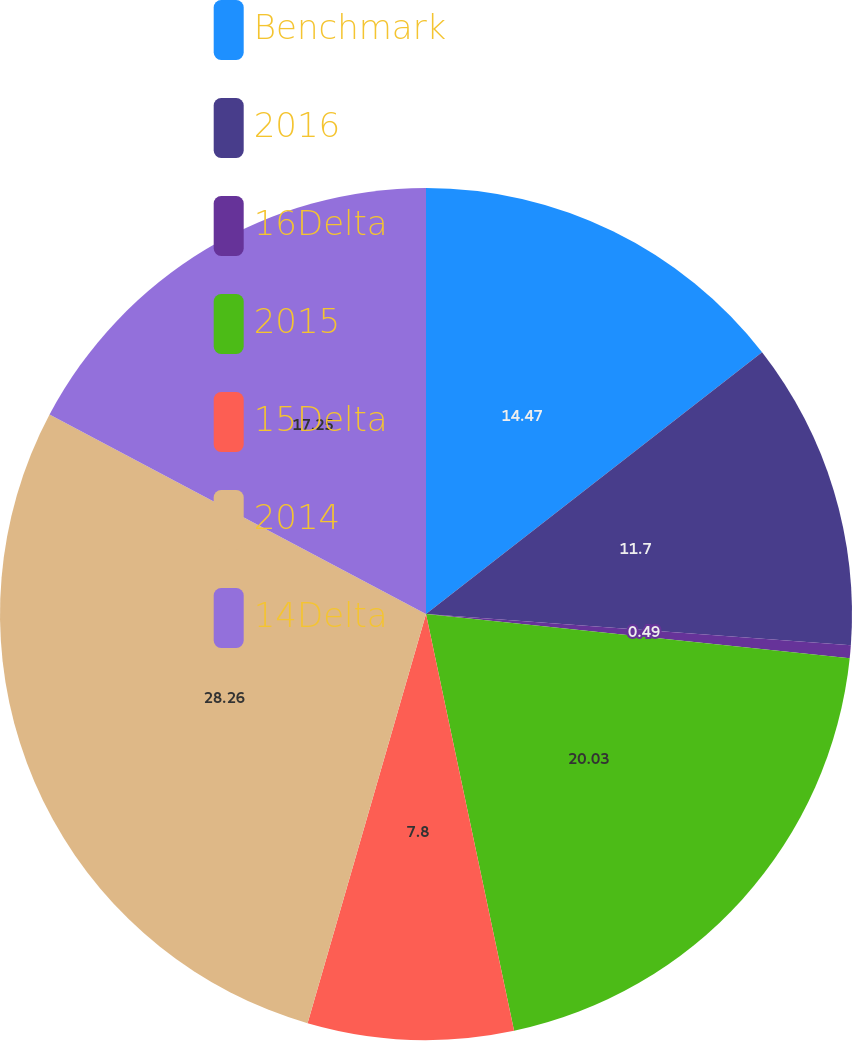Convert chart. <chart><loc_0><loc_0><loc_500><loc_500><pie_chart><fcel>Benchmark<fcel>2016<fcel>16Delta<fcel>2015<fcel>15Delta<fcel>2014<fcel>14Delta<nl><fcel>14.47%<fcel>11.7%<fcel>0.49%<fcel>20.03%<fcel>7.8%<fcel>28.27%<fcel>17.25%<nl></chart> 